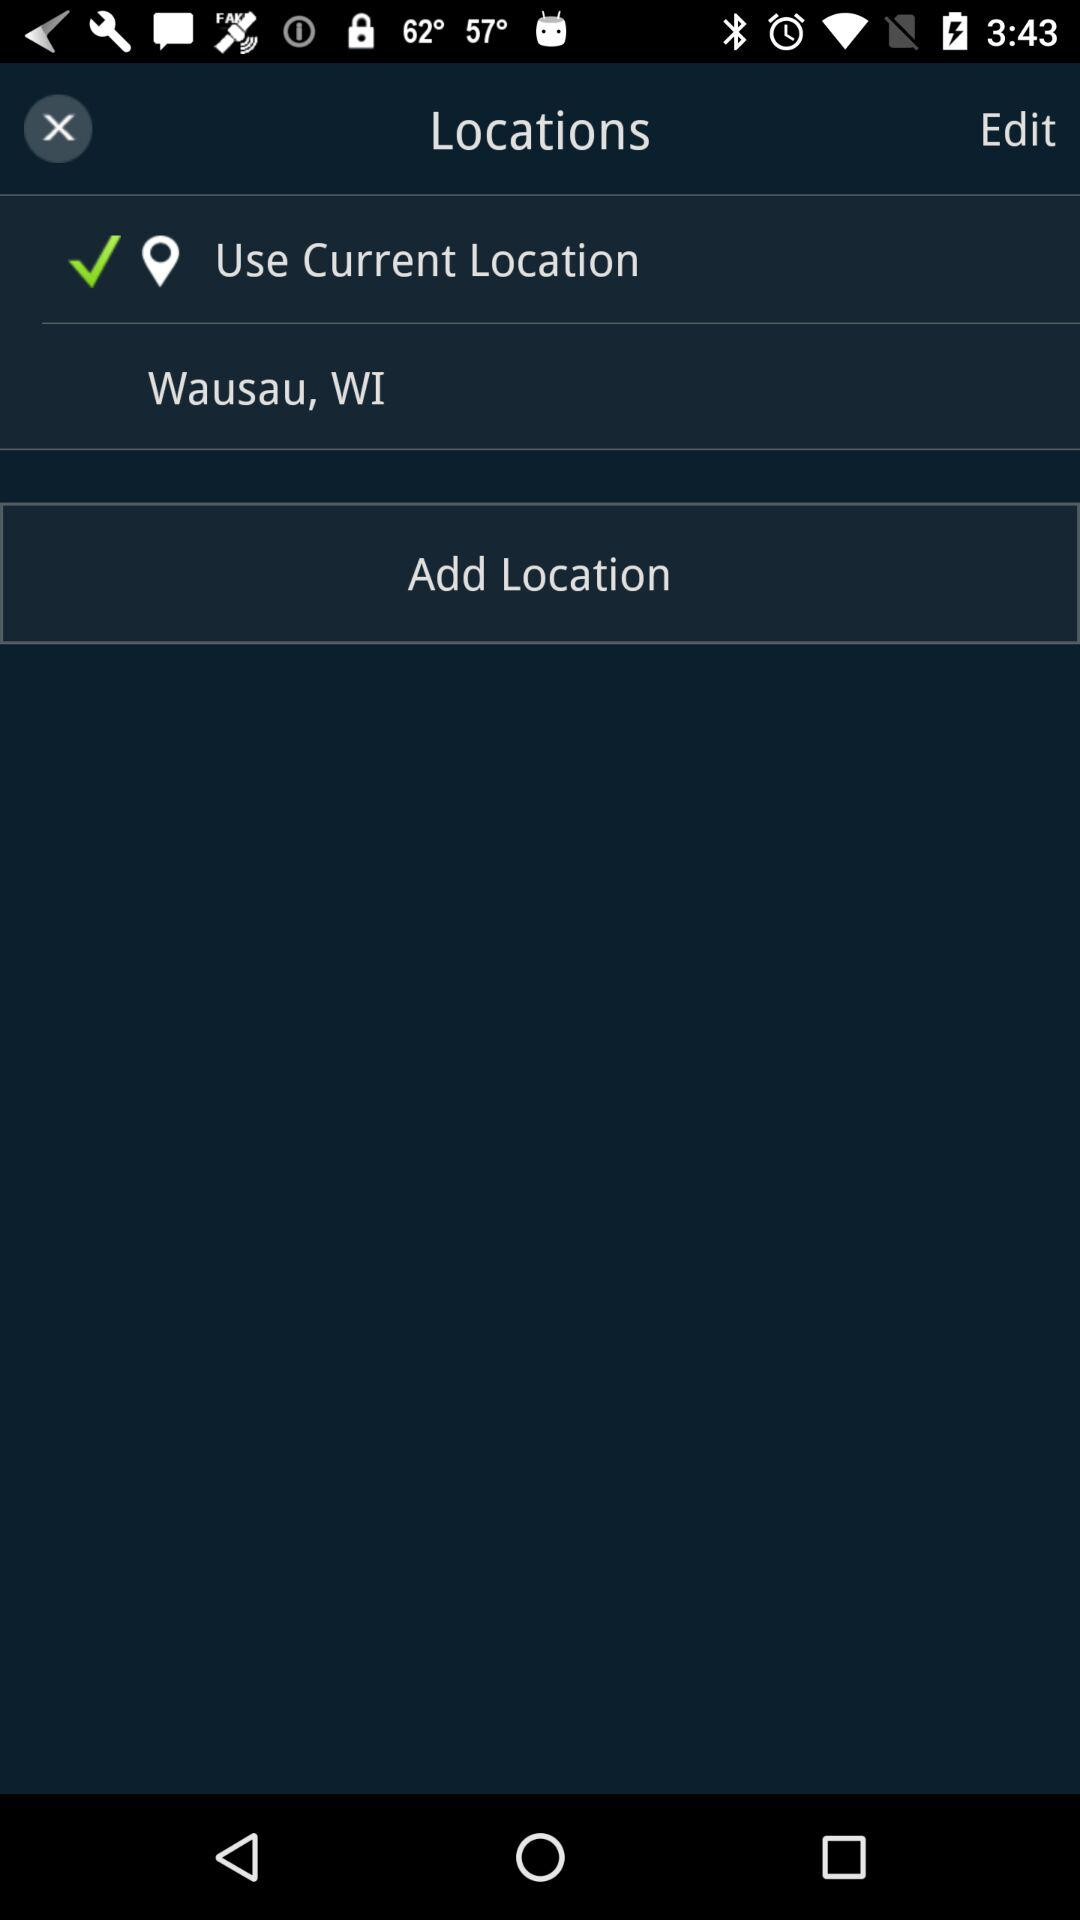How many locations are there on this screen?
Answer the question using a single word or phrase. 2 